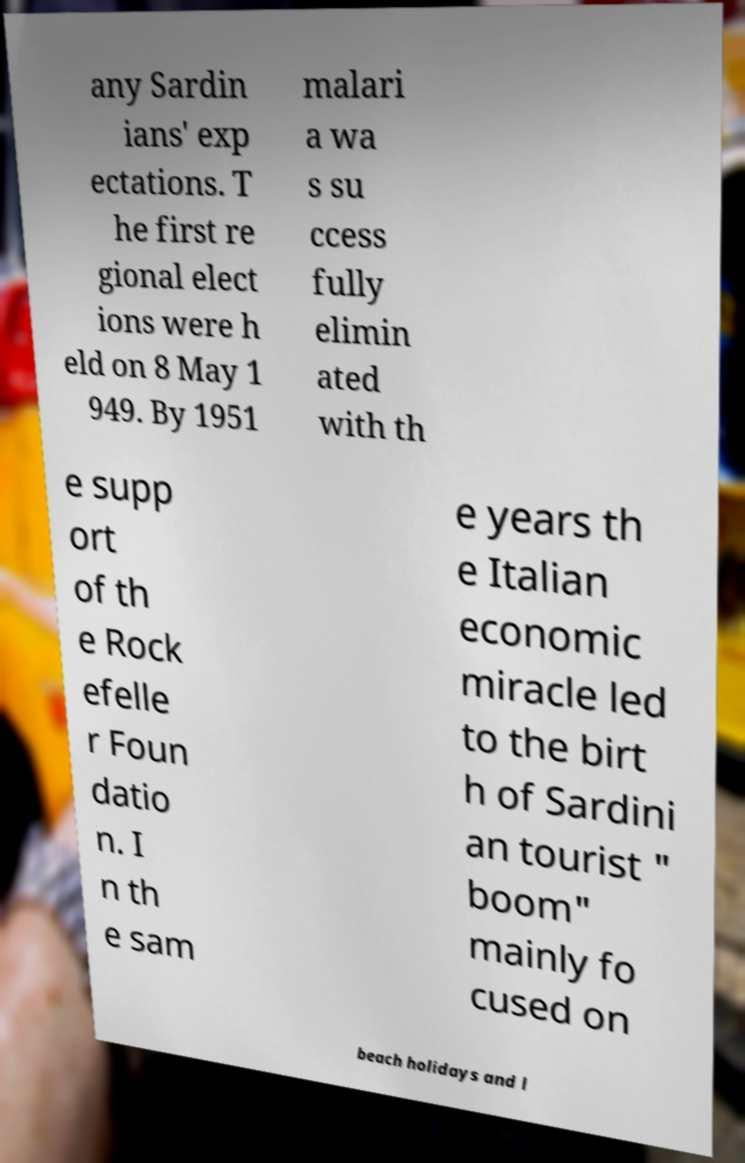What messages or text are displayed in this image? I need them in a readable, typed format. any Sardin ians' exp ectations. T he first re gional elect ions were h eld on 8 May 1 949. By 1951 malari a wa s su ccess fully elimin ated with th e supp ort of th e Rock efelle r Foun datio n. I n th e sam e years th e Italian economic miracle led to the birt h of Sardini an tourist " boom" mainly fo cused on beach holidays and l 